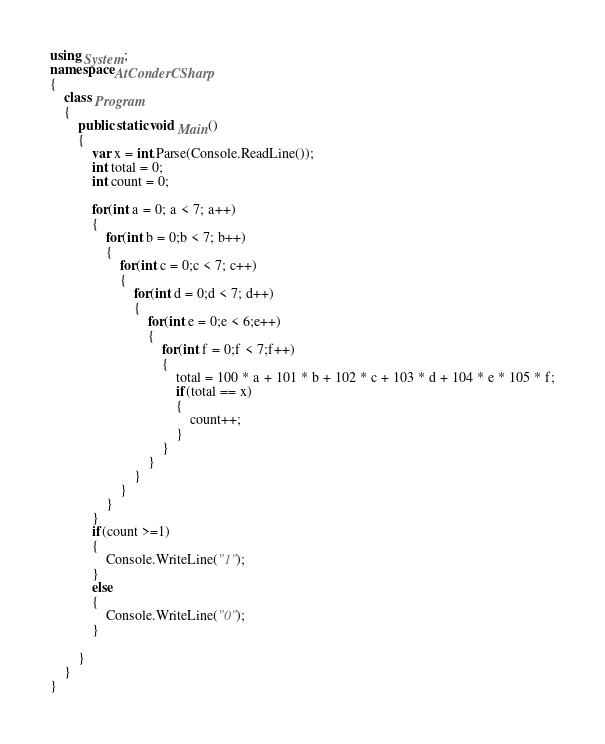<code> <loc_0><loc_0><loc_500><loc_500><_C#_>using System;
namespace AtConderCSharp
{
    class Program
    {
        public static void Main()
        {
            var x = int.Parse(Console.ReadLine());
            int total = 0;
            int count = 0;

            for(int a = 0; a < 7; a++)
            {
                for(int b = 0;b < 7; b++)
                {
                    for(int c = 0;c < 7; c++)
                    {
                        for(int d = 0;d < 7; d++)
                        {
                            for(int e = 0;e < 6;e++) 
                            {
                                for(int f = 0;f < 7;f++)
                                {
                                    total = 100 * a + 101 * b + 102 * c + 103 * d + 104 * e * 105 * f;
                                    if(total == x)
                                    {
                                        count++;
                                    }
                                }
                            }
                        }
                    }
                }
            }
            if(count >=1)
            {
                Console.WriteLine("1");
            }
            else
            {
                Console.WriteLine("0");
            }

        }
    }
}</code> 